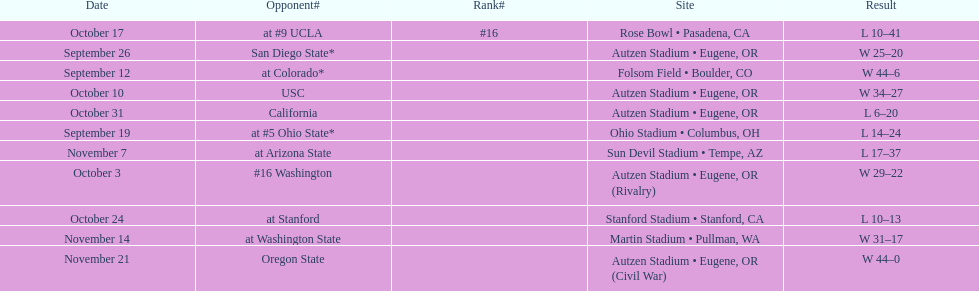What is the number of away games ? 6. 